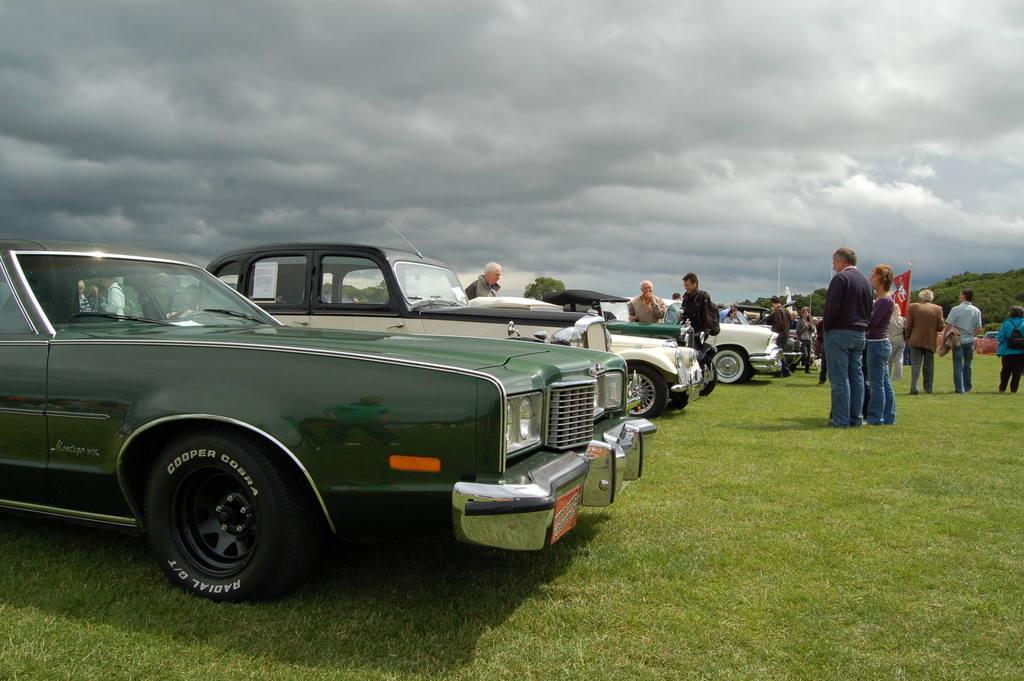How would you summarize this image in a sentence or two? In this picture in the front there's grass on the ground. In the center there are vehicles and in the background there are persons, trees, there is a flag and the sky is cloudy. 